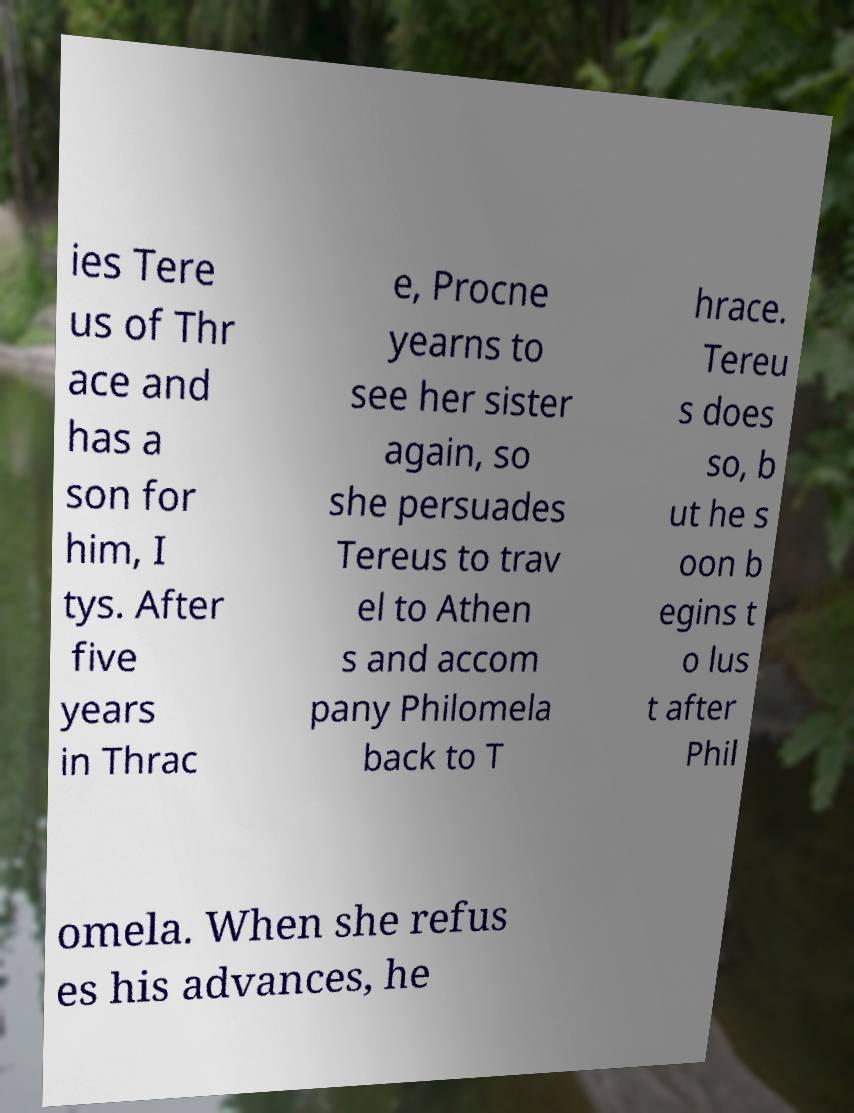Could you assist in decoding the text presented in this image and type it out clearly? ies Tere us of Thr ace and has a son for him, I tys. After five years in Thrac e, Procne yearns to see her sister again, so she persuades Tereus to trav el to Athen s and accom pany Philomela back to T hrace. Tereu s does so, b ut he s oon b egins t o lus t after Phil omela. When she refus es his advances, he 